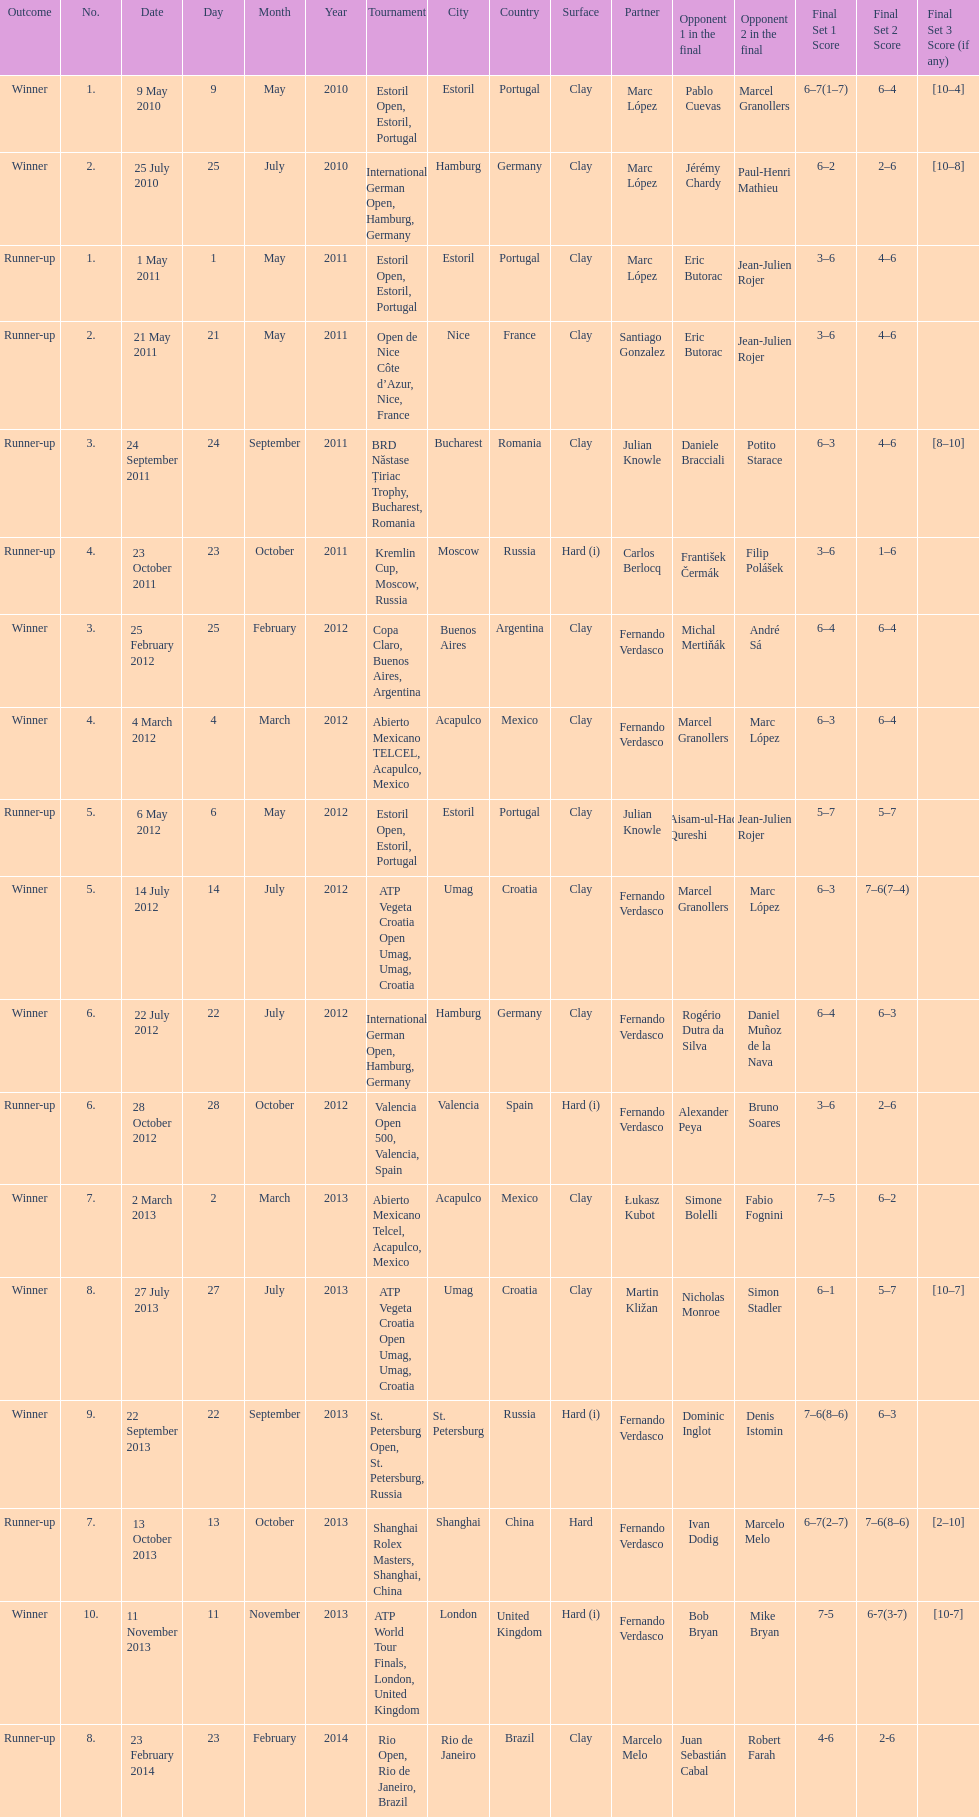What is the number of times a hard surface was used? 5. 